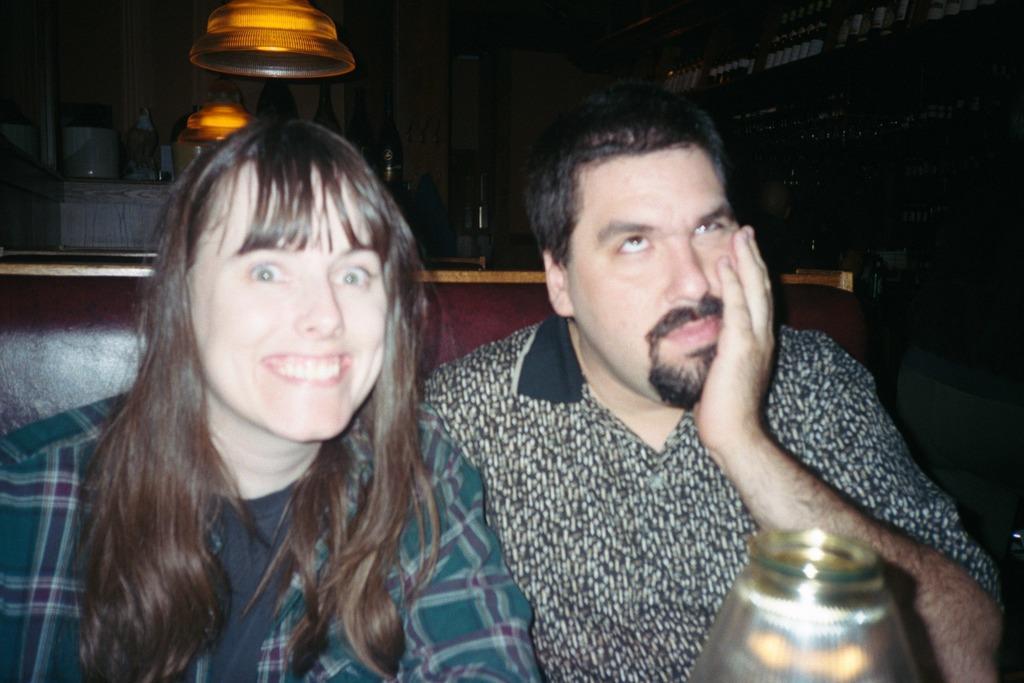Describe this image in one or two sentences. In this image I can see two people with different color dresses. I can see these people are sitting on the couch and there is an object in-front of these people. In the background I can see the bottles and there is a black background. 